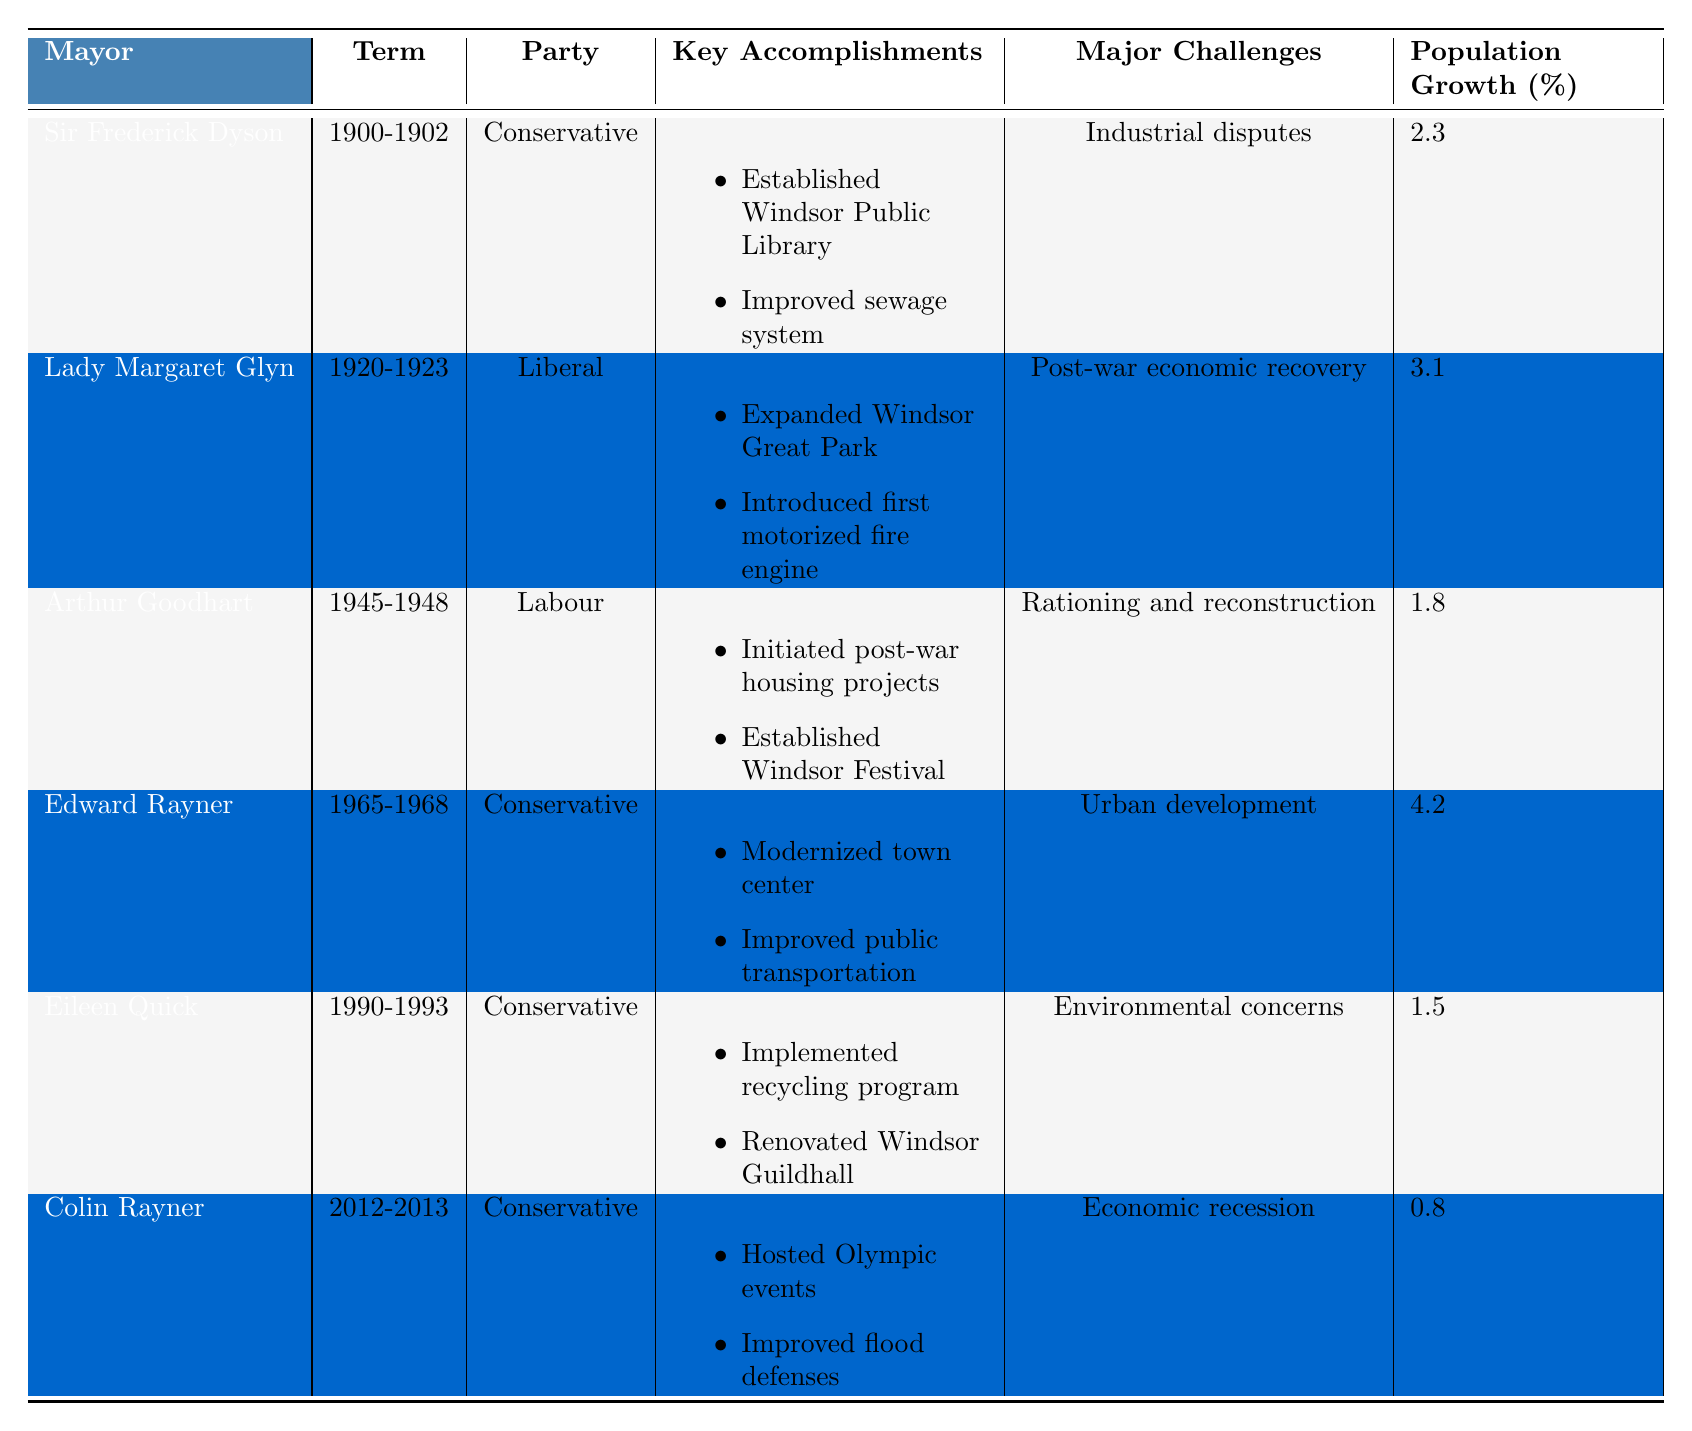What was the term duration of Edward Rayner? Edward Rayner served from 1965 to 1968, which is a duration of three years.
Answer: Three years Which mayor had the highest population growth percentage during their term? Edward Rayner had a population growth of 4.2%, which is the highest among all mayors listed.
Answer: Edward Rayner Did Lady Margaret Glyn accomplish the establishment of the Windsor Public Library? No, the establishment of the Windsor Public Library was accomplished by Sir Frederick Dyson.
Answer: No What was the major challenge faced by Arthur Goodhart during his term? According to the table, Arthur Goodhart faced the challenge of rationing and reconstruction during his term.
Answer: Rationing and reconstruction Calculate the average population growth percentage of all listed mayors. The population growth percentages are 2.3, 3.1, 1.8, 4.2, 1.5, and 0.8. The sum is (2.3 + 3.1 + 1.8 + 4.2 + 1.5 + 0.8) = 13.7. Since there are 6 mayors, the average is 13.7 / 6 = 2.283.
Answer: Approximately 2.28 Which political party had the most mayors serving in the given data? By reviewing the table, Conservative is the party with four mayors: Sir Frederick Dyson, Edward Rayner, Eileen Quick, and Colin Rayner.
Answer: Conservative What specific key accomplishment did Eileen Quick achieve during her term? Eileen Quick implemented a recycling program and renovated Windsor Guildhall, both listed as key accomplishments during her term from 1990-1993.
Answer: Implemented recycling program Was the introduction of the first motorized fire engine a key accomplishment of a Labour Party mayor? No, the introduction of the first motorized fire engine was accomplished by Lady Margaret Glyn from the Liberal Party.
Answer: No Identify the time period during which Sir Frederick Dyson served as mayor. Sir Frederick Dyson's term started in 1900 and ended in 1902, making it a short period of two years.
Answer: 1900-1902 What key accomplishment is associated with Colin Rayner? Colin Rayner hosted Olympic events and improved flood defenses during his term from 2012 to 2013.
Answer: Hosted Olympic events Determine if any mayor faced environmental concerns as a major challenge. Yes, Eileen Quick faced environmental concerns as a major challenge during her term.
Answer: Yes 